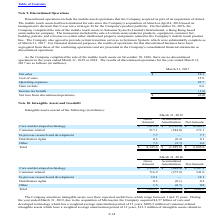According to Microchip Technology's financial document, What was the net amount of Customer-related assets? According to the financial document, 373.1 (in millions). The relevant text states: "Customer-related 917.1 (544.0) 373.1..." Also, What was the gross amount of Core and developed technology assets? According to the financial document, 7,413.0 (in millions). The relevant text states: "Core and developed technology $ 7,413.0 $ (1,112.9) $ 6,300.1..." Also, What was the Accumulated Amortization of Other assets? According to the financial document, (2.7) (in millions). The relevant text states: "Other 7.3 (2.7) 4.6..." Also, can you calculate: What was the difference between the gross amount of Distribution rights and Other assets? Based on the calculation: 7.3-0.3, the result is 7 (in millions). This is based on the information: "Other 7.3 (2.7) 4.6 Distribution rights 0.3 (0.2) 0.1..." The key data points involved are: 0.3, 7.3. Also, can you calculate: What was the difference between the net amount of Customer-related assets and In-process research and development assets? Based on the calculation: 373.1-7.7, the result is 365.4 (in millions). This is based on the information: "Customer-related 917.1 (544.0) 373.1 In-process research and development 7.7 — 7.7..." The key data points involved are: 373.1, 7.7. Also, can you calculate: What was the net amount of Core and developed technology assets as a percentage of total intangible assets? Based on the calculation: 6,300.1/6,685.6, the result is 94.23 (percentage). This is based on the information: "Total $ 8,345.4 $ (1,659.8) $ 6,685.6 and developed technology $ 7,413.0 $ (1,112.9) $ 6,300.1..." The key data points involved are: 6,300.1, 6,685.6. 